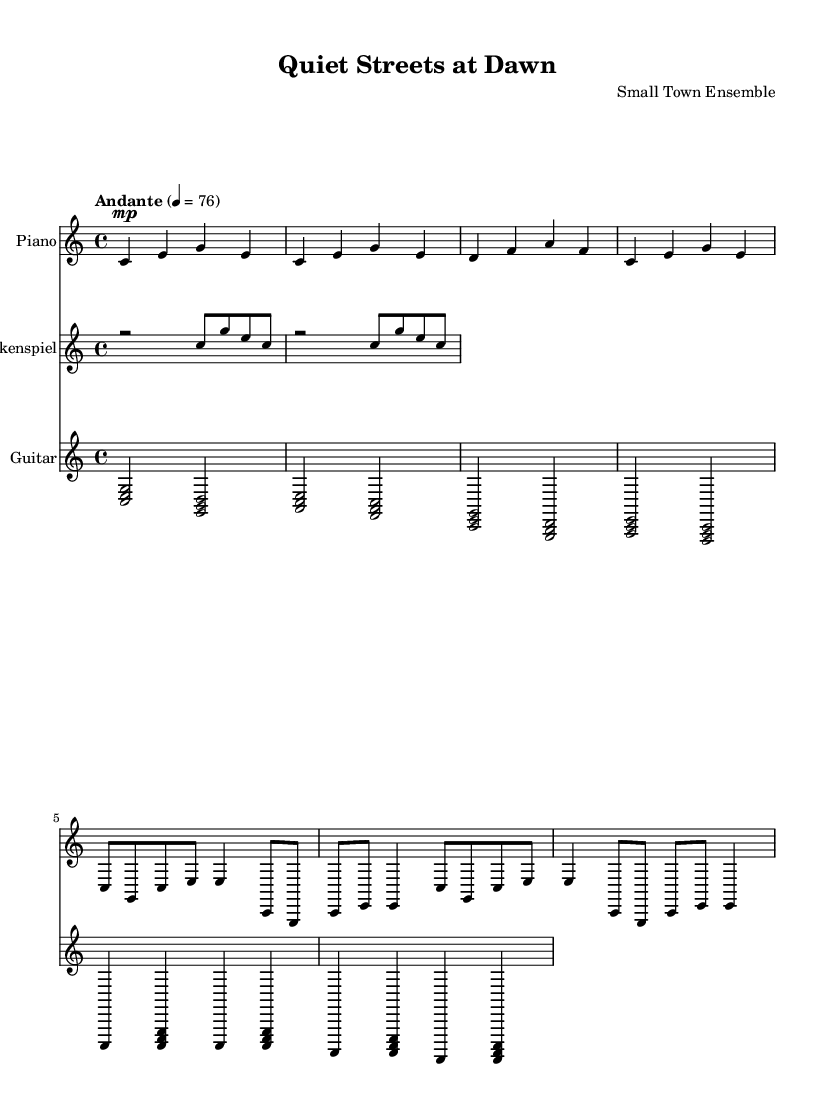What is the key signature of this music? The key signature indicated in the music is C major, which typically contains no sharps or flats. This can be inferred directly from the `\key c \major` instruction in the score.
Answer: C major What is the time signature of this music? The time signature written in the score is 4/4, denoting four beats per measure and a quarter note receives one beat. This is shown in the `\time 4/4` instruction in the score.
Answer: 4/4 What is the tempo marking for this piece? The tempo marking indicates "Andante," which refers to a moderately slow speed. The specified metronome marking is 4 = 76, meaning there are 76 beats per minute. This is displayed in the `\tempo "Andante" 4 = 76` directive.
Answer: Andante How many measures are in the piano section? The piano section consists of eight measures, which can be counted by observing the grouped notation in the music, particularly the vertical lines that denote the end of each measure.
Answer: 8 What instruments are featured in this composition? The composition features three instruments: Piano, Glockenspiel, and Guitar. This is confirmed by the different staff instruments set in the score.
Answer: Piano, Glockenspiel, Guitar What is the dynamic marking for the piano part? The piano part indicates a dynamic marking of "mp," which defines a moderately soft volume. This marking is shown at the beginning of the piano staff as `\mp`.
Answer: mp How does the rhythm create a minimalist feel? The rhythmic pattern is repetitive and sparse, with simple melodies that reflect the quietness of small-town life. The overall structure emphasizes subtle variations and understated harmony, characteristic of minimalist music.
Answer: Repetitive and sparse rhythm 